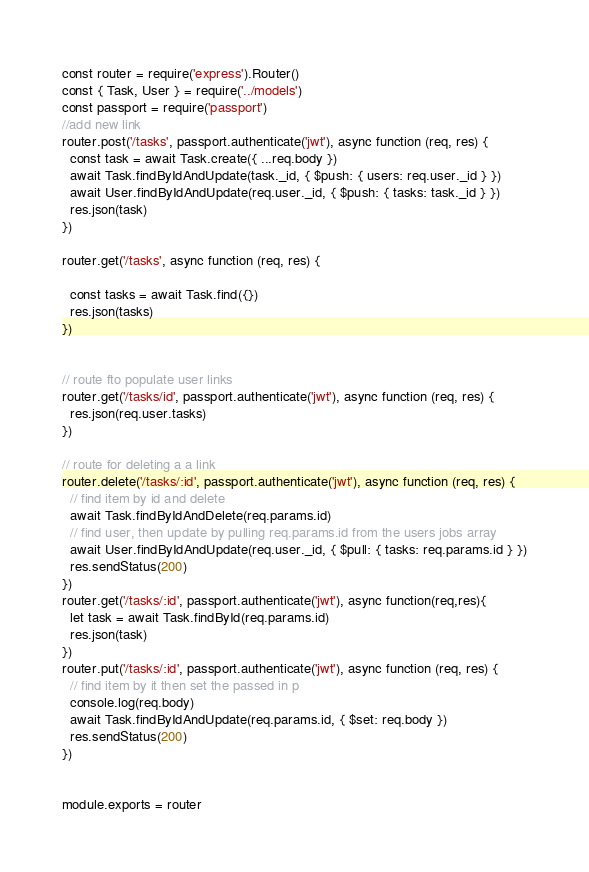Convert code to text. <code><loc_0><loc_0><loc_500><loc_500><_JavaScript_>const router = require('express').Router()
const { Task, User } = require('../models')
const passport = require('passport')
//add new link
router.post('/tasks', passport.authenticate('jwt'), async function (req, res) {
  const task = await Task.create({ ...req.body })
  await Task.findByIdAndUpdate(task._id, { $push: { users: req.user._id } })
  await User.findByIdAndUpdate(req.user._id, { $push: { tasks: task._id } })
  res.json(task)
})

router.get('/tasks', async function (req, res) {

  const tasks = await Task.find({})
  res.json(tasks)
})


// route fto populate user links
router.get('/tasks/id', passport.authenticate('jwt'), async function (req, res) {
  res.json(req.user.tasks)
})

// route for deleting a a link
router.delete('/tasks/:id', passport.authenticate('jwt'), async function (req, res) {
  // find item by id and delete
  await Task.findByIdAndDelete(req.params.id)
  // find user, then update by pulling req.params.id from the users jobs array
  await User.findByIdAndUpdate(req.user._id, { $pull: { tasks: req.params.id } })
  res.sendStatus(200)
})
router.get('/tasks/:id', passport.authenticate('jwt'), async function(req,res){
  let task = await Task.findById(req.params.id)
  res.json(task)
})
router.put('/tasks/:id', passport.authenticate('jwt'), async function (req, res) {
  // find item by it then set the passed in p
  console.log(req.body)
  await Task.findByIdAndUpdate(req.params.id, { $set: req.body })
  res.sendStatus(200)
})


module.exports = router</code> 